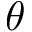Convert formula to latex. <formula><loc_0><loc_0><loc_500><loc_500>\theta</formula> 